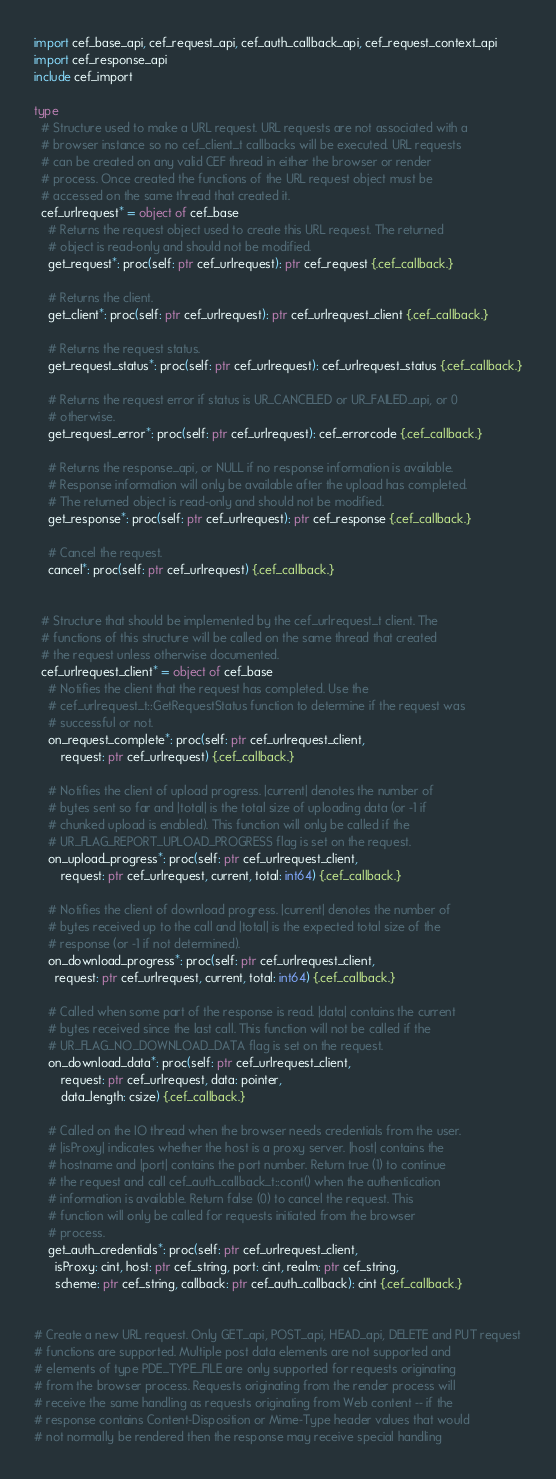<code> <loc_0><loc_0><loc_500><loc_500><_Nim_>import cef_base_api, cef_request_api, cef_auth_callback_api, cef_request_context_api
import cef_response_api
include cef_import

type
  # Structure used to make a URL request. URL requests are not associated with a
  # browser instance so no cef_client_t callbacks will be executed. URL requests
  # can be created on any valid CEF thread in either the browser or render
  # process. Once created the functions of the URL request object must be
  # accessed on the same thread that created it.
  cef_urlrequest* = object of cef_base
    # Returns the request object used to create this URL request. The returned
    # object is read-only and should not be modified.
    get_request*: proc(self: ptr cef_urlrequest): ptr cef_request {.cef_callback.}

    # Returns the client.
    get_client*: proc(self: ptr cef_urlrequest): ptr cef_urlrequest_client {.cef_callback.}

    # Returns the request status.
    get_request_status*: proc(self: ptr cef_urlrequest): cef_urlrequest_status {.cef_callback.}

    # Returns the request error if status is UR_CANCELED or UR_FAILED_api, or 0
    # otherwise.
    get_request_error*: proc(self: ptr cef_urlrequest): cef_errorcode {.cef_callback.}

    # Returns the response_api, or NULL if no response information is available.
    # Response information will only be available after the upload has completed.
    # The returned object is read-only and should not be modified.
    get_response*: proc(self: ptr cef_urlrequest): ptr cef_response {.cef_callback.}

    # Cancel the request.
    cancel*: proc(self: ptr cef_urlrequest) {.cef_callback.}


  # Structure that should be implemented by the cef_urlrequest_t client. The
  # functions of this structure will be called on the same thread that created
  # the request unless otherwise documented.
  cef_urlrequest_client* = object of cef_base
    # Notifies the client that the request has completed. Use the
    # cef_urlrequest_t::GetRequestStatus function to determine if the request was
    # successful or not.
    on_request_complete*: proc(self: ptr cef_urlrequest_client,
        request: ptr cef_urlrequest) {.cef_callback.}

    # Notifies the client of upload progress. |current| denotes the number of
    # bytes sent so far and |total| is the total size of uploading data (or -1 if
    # chunked upload is enabled). This function will only be called if the
    # UR_FLAG_REPORT_UPLOAD_PROGRESS flag is set on the request.
    on_upload_progress*: proc(self: ptr cef_urlrequest_client,
        request: ptr cef_urlrequest, current, total: int64) {.cef_callback.}

    # Notifies the client of download progress. |current| denotes the number of
    # bytes received up to the call and |total| is the expected total size of the
    # response (or -1 if not determined).
    on_download_progress*: proc(self: ptr cef_urlrequest_client,
      request: ptr cef_urlrequest, current, total: int64) {.cef_callback.}

    # Called when some part of the response is read. |data| contains the current
    # bytes received since the last call. This function will not be called if the
    # UR_FLAG_NO_DOWNLOAD_DATA flag is set on the request.
    on_download_data*: proc(self: ptr cef_urlrequest_client,
        request: ptr cef_urlrequest, data: pointer,
        data_length: csize) {.cef_callback.}

    # Called on the IO thread when the browser needs credentials from the user.
    # |isProxy| indicates whether the host is a proxy server. |host| contains the
    # hostname and |port| contains the port number. Return true (1) to continue
    # the request and call cef_auth_callback_t::cont() when the authentication
    # information is available. Return false (0) to cancel the request. This
    # function will only be called for requests initiated from the browser
    # process.
    get_auth_credentials*: proc(self: ptr cef_urlrequest_client,
      isProxy: cint, host: ptr cef_string, port: cint, realm: ptr cef_string,
      scheme: ptr cef_string, callback: ptr cef_auth_callback): cint {.cef_callback.}


# Create a new URL request. Only GET_api, POST_api, HEAD_api, DELETE and PUT request
# functions are supported. Multiple post data elements are not supported and
# elements of type PDE_TYPE_FILE are only supported for requests originating
# from the browser process. Requests originating from the render process will
# receive the same handling as requests originating from Web content -- if the
# response contains Content-Disposition or Mime-Type header values that would
# not normally be rendered then the response may receive special handling</code> 